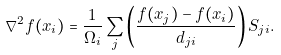Convert formula to latex. <formula><loc_0><loc_0><loc_500><loc_500>\nabla ^ { 2 } f ( x _ { i } ) = \frac { 1 } { \Omega _ { i } } \sum _ { j } \left ( \frac { f ( x _ { j } ) - f ( x _ { i } ) } { d _ { j i } } \right ) S _ { j i } .</formula> 